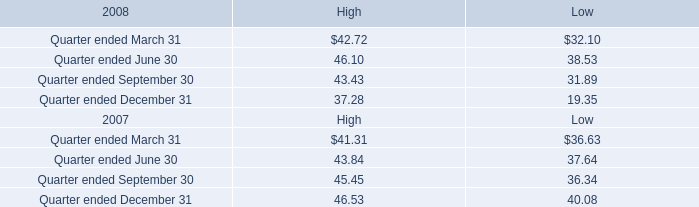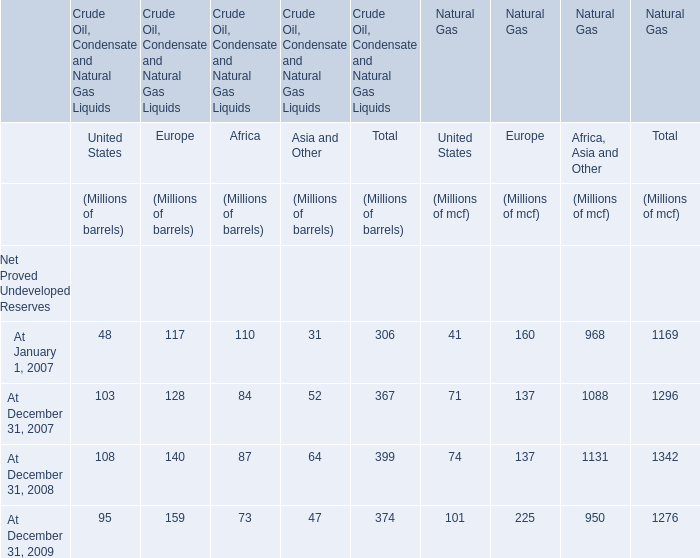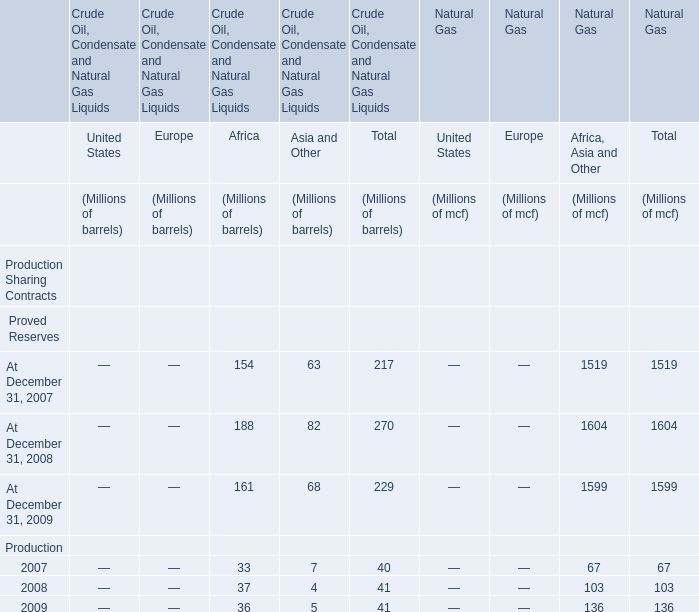At December 31, what year is the Net Proved Undeveloped Reserves of Europe for Natural Gas the most? 
Answer: 2009. 